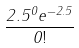Convert formula to latex. <formula><loc_0><loc_0><loc_500><loc_500>\frac { 2 . 5 ^ { 0 } e ^ { - 2 . 5 } } { 0 ! }</formula> 